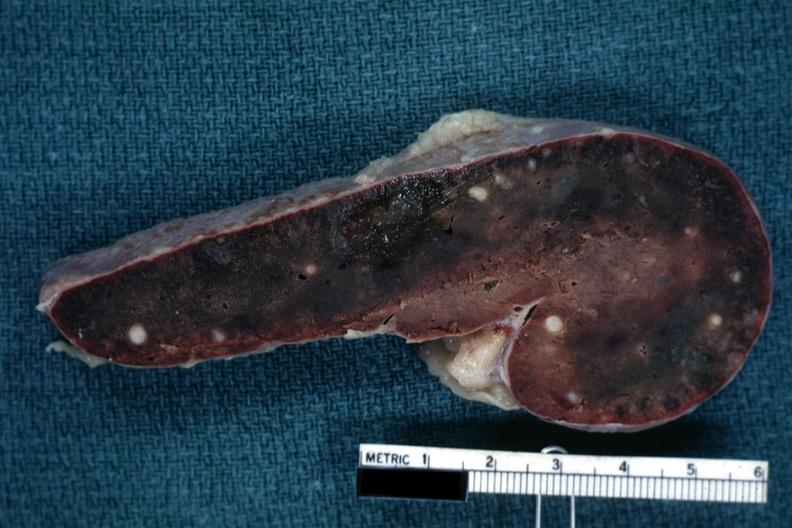s lower chest and abdomen anterior present?
Answer the question using a single word or phrase. No 